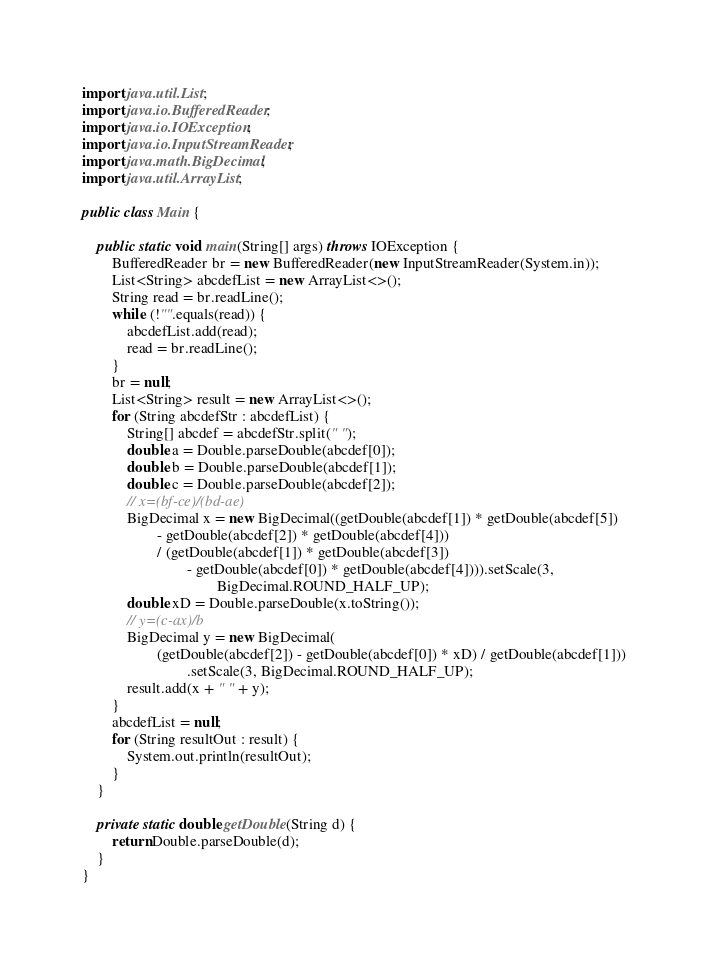<code> <loc_0><loc_0><loc_500><loc_500><_Java_>import java.util.List;
import java.io.BufferedReader;
import java.io.IOException;
import java.io.InputStreamReader;
import java.math.BigDecimal;
import java.util.ArrayList;

public class Main {

    public static void main(String[] args) throws IOException {
        BufferedReader br = new BufferedReader(new InputStreamReader(System.in));
        List<String> abcdefList = new ArrayList<>();
        String read = br.readLine();
        while (!"".equals(read)) {
            abcdefList.add(read);
            read = br.readLine();
        }
        br = null;
        List<String> result = new ArrayList<>();
        for (String abcdefStr : abcdefList) {
            String[] abcdef = abcdefStr.split(" ");
            double a = Double.parseDouble(abcdef[0]);
            double b = Double.parseDouble(abcdef[1]);
            double c = Double.parseDouble(abcdef[2]);
            // x=(bf-ce)/(bd-ae)
            BigDecimal x = new BigDecimal((getDouble(abcdef[1]) * getDouble(abcdef[5])
                    - getDouble(abcdef[2]) * getDouble(abcdef[4]))
                    / (getDouble(abcdef[1]) * getDouble(abcdef[3])
                            - getDouble(abcdef[0]) * getDouble(abcdef[4]))).setScale(3,
                                    BigDecimal.ROUND_HALF_UP);
            double xD = Double.parseDouble(x.toString());
            // y=(c-ax)/b
            BigDecimal y = new BigDecimal(
                    (getDouble(abcdef[2]) - getDouble(abcdef[0]) * xD) / getDouble(abcdef[1]))
                            .setScale(3, BigDecimal.ROUND_HALF_UP);
            result.add(x + " " + y);
        }
        abcdefList = null;
        for (String resultOut : result) {
            System.out.println(resultOut);
        }
    }

    private static double getDouble(String d) {
        return Double.parseDouble(d);
    }
}</code> 